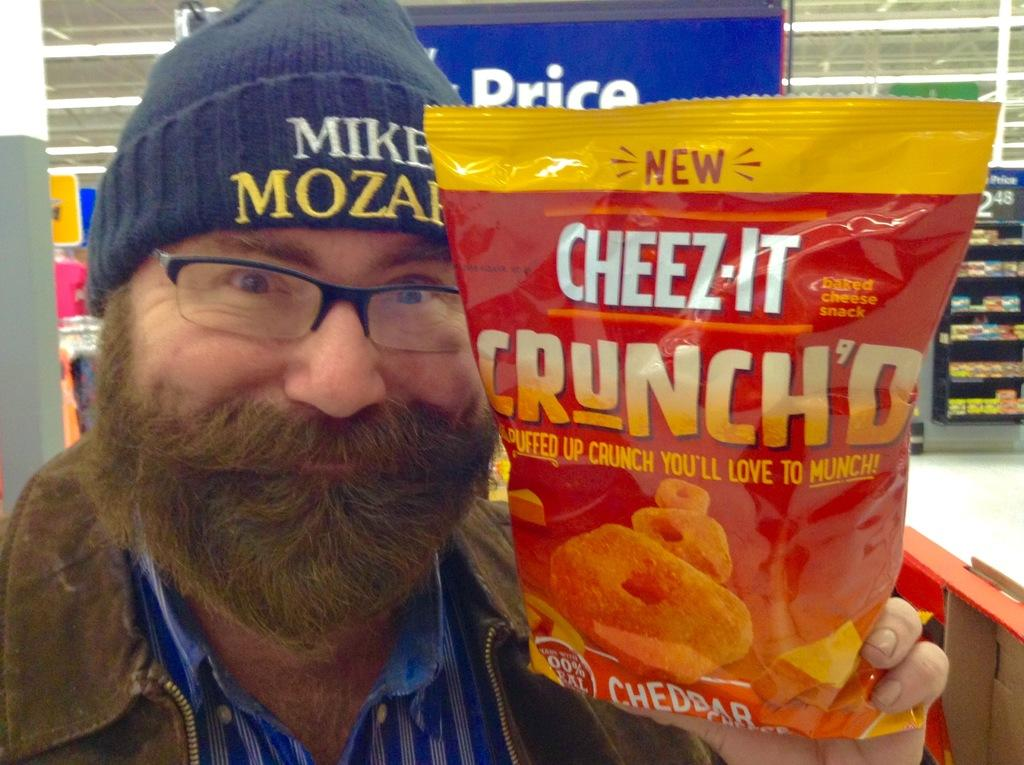What is the person in the image holding? The person is holding a packet. Can you describe the person's attire in the image? The person is wearing a cap and spectacles. What can be seen in the background of the image? There is a floor, a pillar, a poster, shelves, lights, and some objects in the background of the image. How many items can be seen on the shelves in the background? The number of items on the shelves cannot be determined from the image. What type of lighting is present in the background of the image? There are lights in the background of the image, but their type cannot be determined from the image. How many dimes are visible on the shelves in the image? There are no dimes visible on the shelves in the image. What type of jewel is featured in the poster in the background of the image? There is no poster featuring a jewel in the background of the image. 